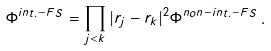<formula> <loc_0><loc_0><loc_500><loc_500>\Phi ^ { i n t . - F S } = \prod _ { j < k } | { r _ { j } } - { r } _ { k } | ^ { 2 } \Phi ^ { n o n - i n t . - F S } \, .</formula> 